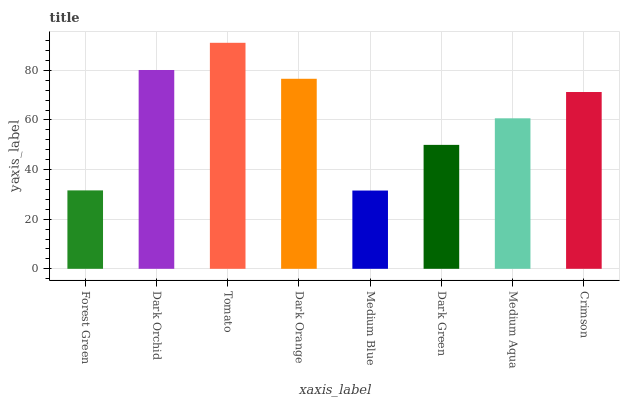Is Medium Blue the minimum?
Answer yes or no. Yes. Is Tomato the maximum?
Answer yes or no. Yes. Is Dark Orchid the minimum?
Answer yes or no. No. Is Dark Orchid the maximum?
Answer yes or no. No. Is Dark Orchid greater than Forest Green?
Answer yes or no. Yes. Is Forest Green less than Dark Orchid?
Answer yes or no. Yes. Is Forest Green greater than Dark Orchid?
Answer yes or no. No. Is Dark Orchid less than Forest Green?
Answer yes or no. No. Is Crimson the high median?
Answer yes or no. Yes. Is Medium Aqua the low median?
Answer yes or no. Yes. Is Medium Blue the high median?
Answer yes or no. No. Is Tomato the low median?
Answer yes or no. No. 